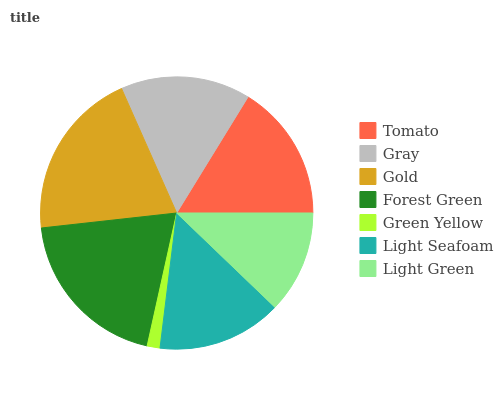Is Green Yellow the minimum?
Answer yes or no. Yes. Is Gold the maximum?
Answer yes or no. Yes. Is Gray the minimum?
Answer yes or no. No. Is Gray the maximum?
Answer yes or no. No. Is Tomato greater than Gray?
Answer yes or no. Yes. Is Gray less than Tomato?
Answer yes or no. Yes. Is Gray greater than Tomato?
Answer yes or no. No. Is Tomato less than Gray?
Answer yes or no. No. Is Gray the high median?
Answer yes or no. Yes. Is Gray the low median?
Answer yes or no. Yes. Is Light Green the high median?
Answer yes or no. No. Is Tomato the low median?
Answer yes or no. No. 